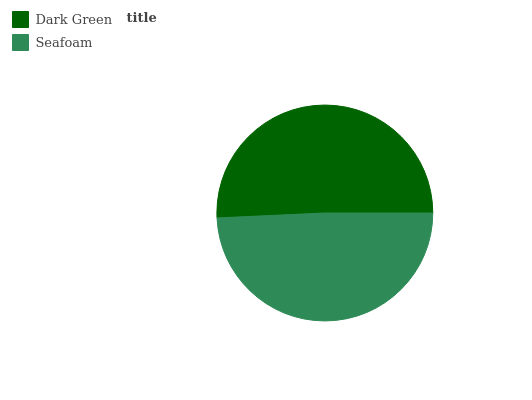Is Seafoam the minimum?
Answer yes or no. Yes. Is Dark Green the maximum?
Answer yes or no. Yes. Is Seafoam the maximum?
Answer yes or no. No. Is Dark Green greater than Seafoam?
Answer yes or no. Yes. Is Seafoam less than Dark Green?
Answer yes or no. Yes. Is Seafoam greater than Dark Green?
Answer yes or no. No. Is Dark Green less than Seafoam?
Answer yes or no. No. Is Dark Green the high median?
Answer yes or no. Yes. Is Seafoam the low median?
Answer yes or no. Yes. Is Seafoam the high median?
Answer yes or no. No. Is Dark Green the low median?
Answer yes or no. No. 